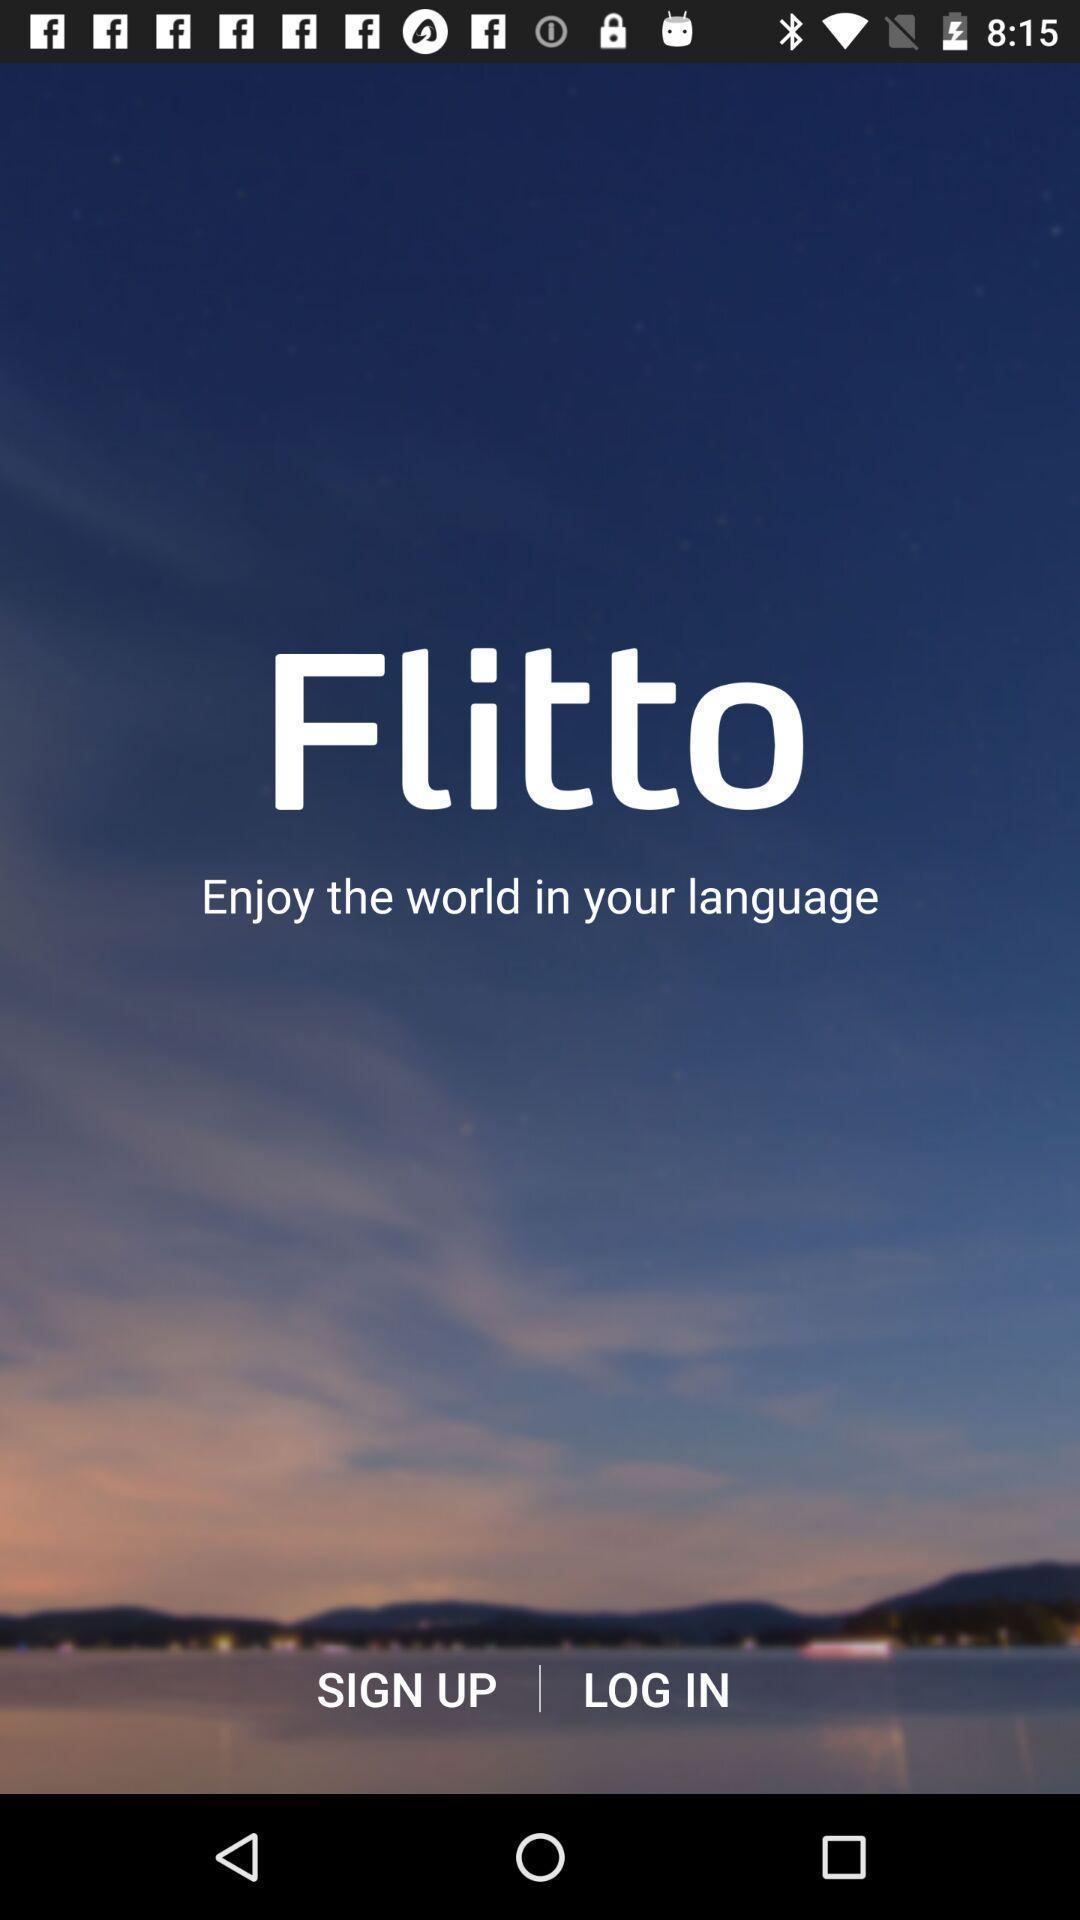Tell me what you see in this picture. Welcome page of translating app. 